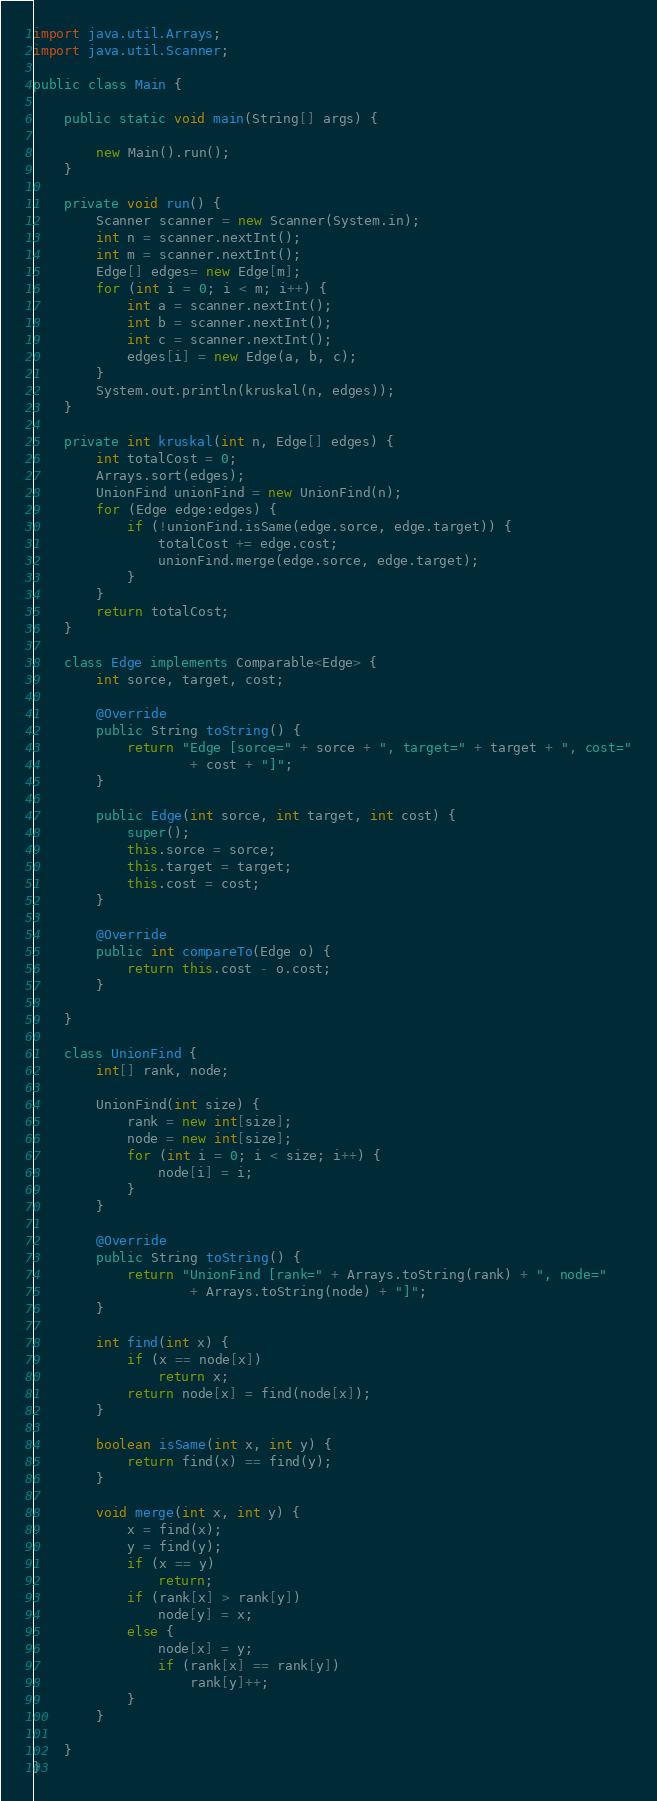<code> <loc_0><loc_0><loc_500><loc_500><_Java_>
import java.util.Arrays;
import java.util.Scanner;

public class Main {

	public static void main(String[] args) {

		new Main().run();
	}

	private void run() {
		Scanner scanner = new Scanner(System.in);
		int n = scanner.nextInt();
		int m = scanner.nextInt();
		Edge[] edges= new Edge[m];
		for (int i = 0; i < m; i++) {
			int a = scanner.nextInt();
			int b = scanner.nextInt();
			int c = scanner.nextInt();
			edges[i] = new Edge(a, b, c);
		}
		System.out.println(kruskal(n, edges));
	}

	private int kruskal(int n, Edge[] edges) {
		int totalCost = 0;
		Arrays.sort(edges);
		UnionFind unionFind = new UnionFind(n);
		for (Edge edge:edges) {
			if (!unionFind.isSame(edge.sorce, edge.target)) {
				totalCost += edge.cost;
				unionFind.merge(edge.sorce, edge.target);
			}
		}
		return totalCost;
	}

	class Edge implements Comparable<Edge> {
		int sorce, target, cost;

		@Override
		public String toString() {
			return "Edge [sorce=" + sorce + ", target=" + target + ", cost="
					+ cost + "]";
		}

		public Edge(int sorce, int target, int cost) {
			super();
			this.sorce = sorce;
			this.target = target;
			this.cost = cost;
		}

		@Override
		public int compareTo(Edge o) {
			return this.cost - o.cost;
		}

	}

	class UnionFind {
		int[] rank, node;

		UnionFind(int size) {
			rank = new int[size];
			node = new int[size];
			for (int i = 0; i < size; i++) {
				node[i] = i;
			}
		}

		@Override
		public String toString() {
			return "UnionFind [rank=" + Arrays.toString(rank) + ", node="
					+ Arrays.toString(node) + "]";
		}

		int find(int x) {
			if (x == node[x])
				return x;
			return node[x] = find(node[x]);
		}

		boolean isSame(int x, int y) {
			return find(x) == find(y);
		}

		void merge(int x, int y) {
			x = find(x);
			y = find(y);
			if (x == y)
				return;
			if (rank[x] > rank[y])
				node[y] = x;
			else {
				node[x] = y;
				if (rank[x] == rank[y])
					rank[y]++;
			}
		}

	}
}</code> 